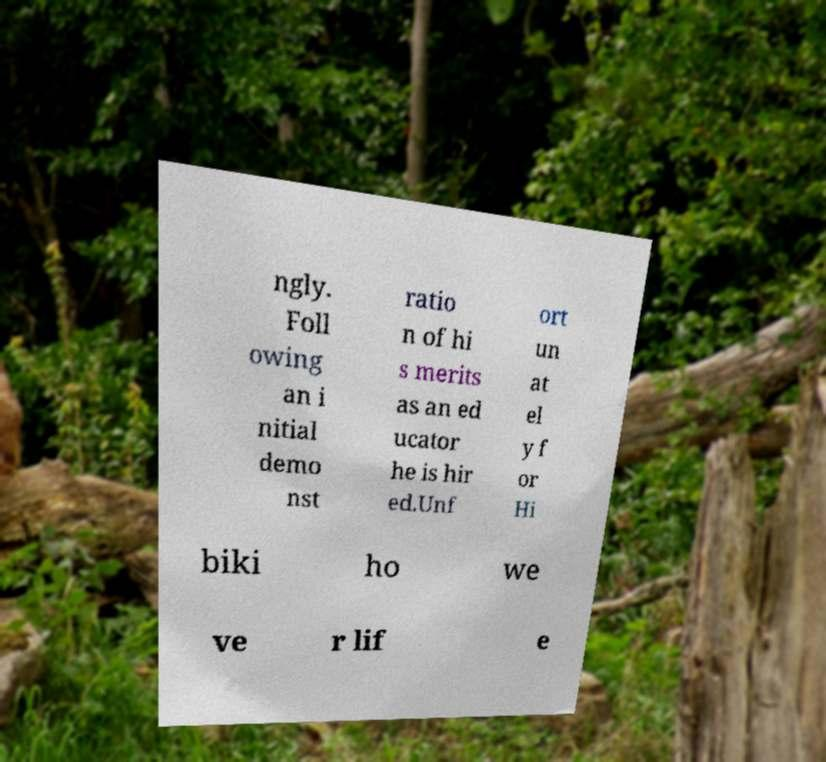For documentation purposes, I need the text within this image transcribed. Could you provide that? ngly. Foll owing an i nitial demo nst ratio n of hi s merits as an ed ucator he is hir ed.Unf ort un at el y f or Hi biki ho we ve r lif e 